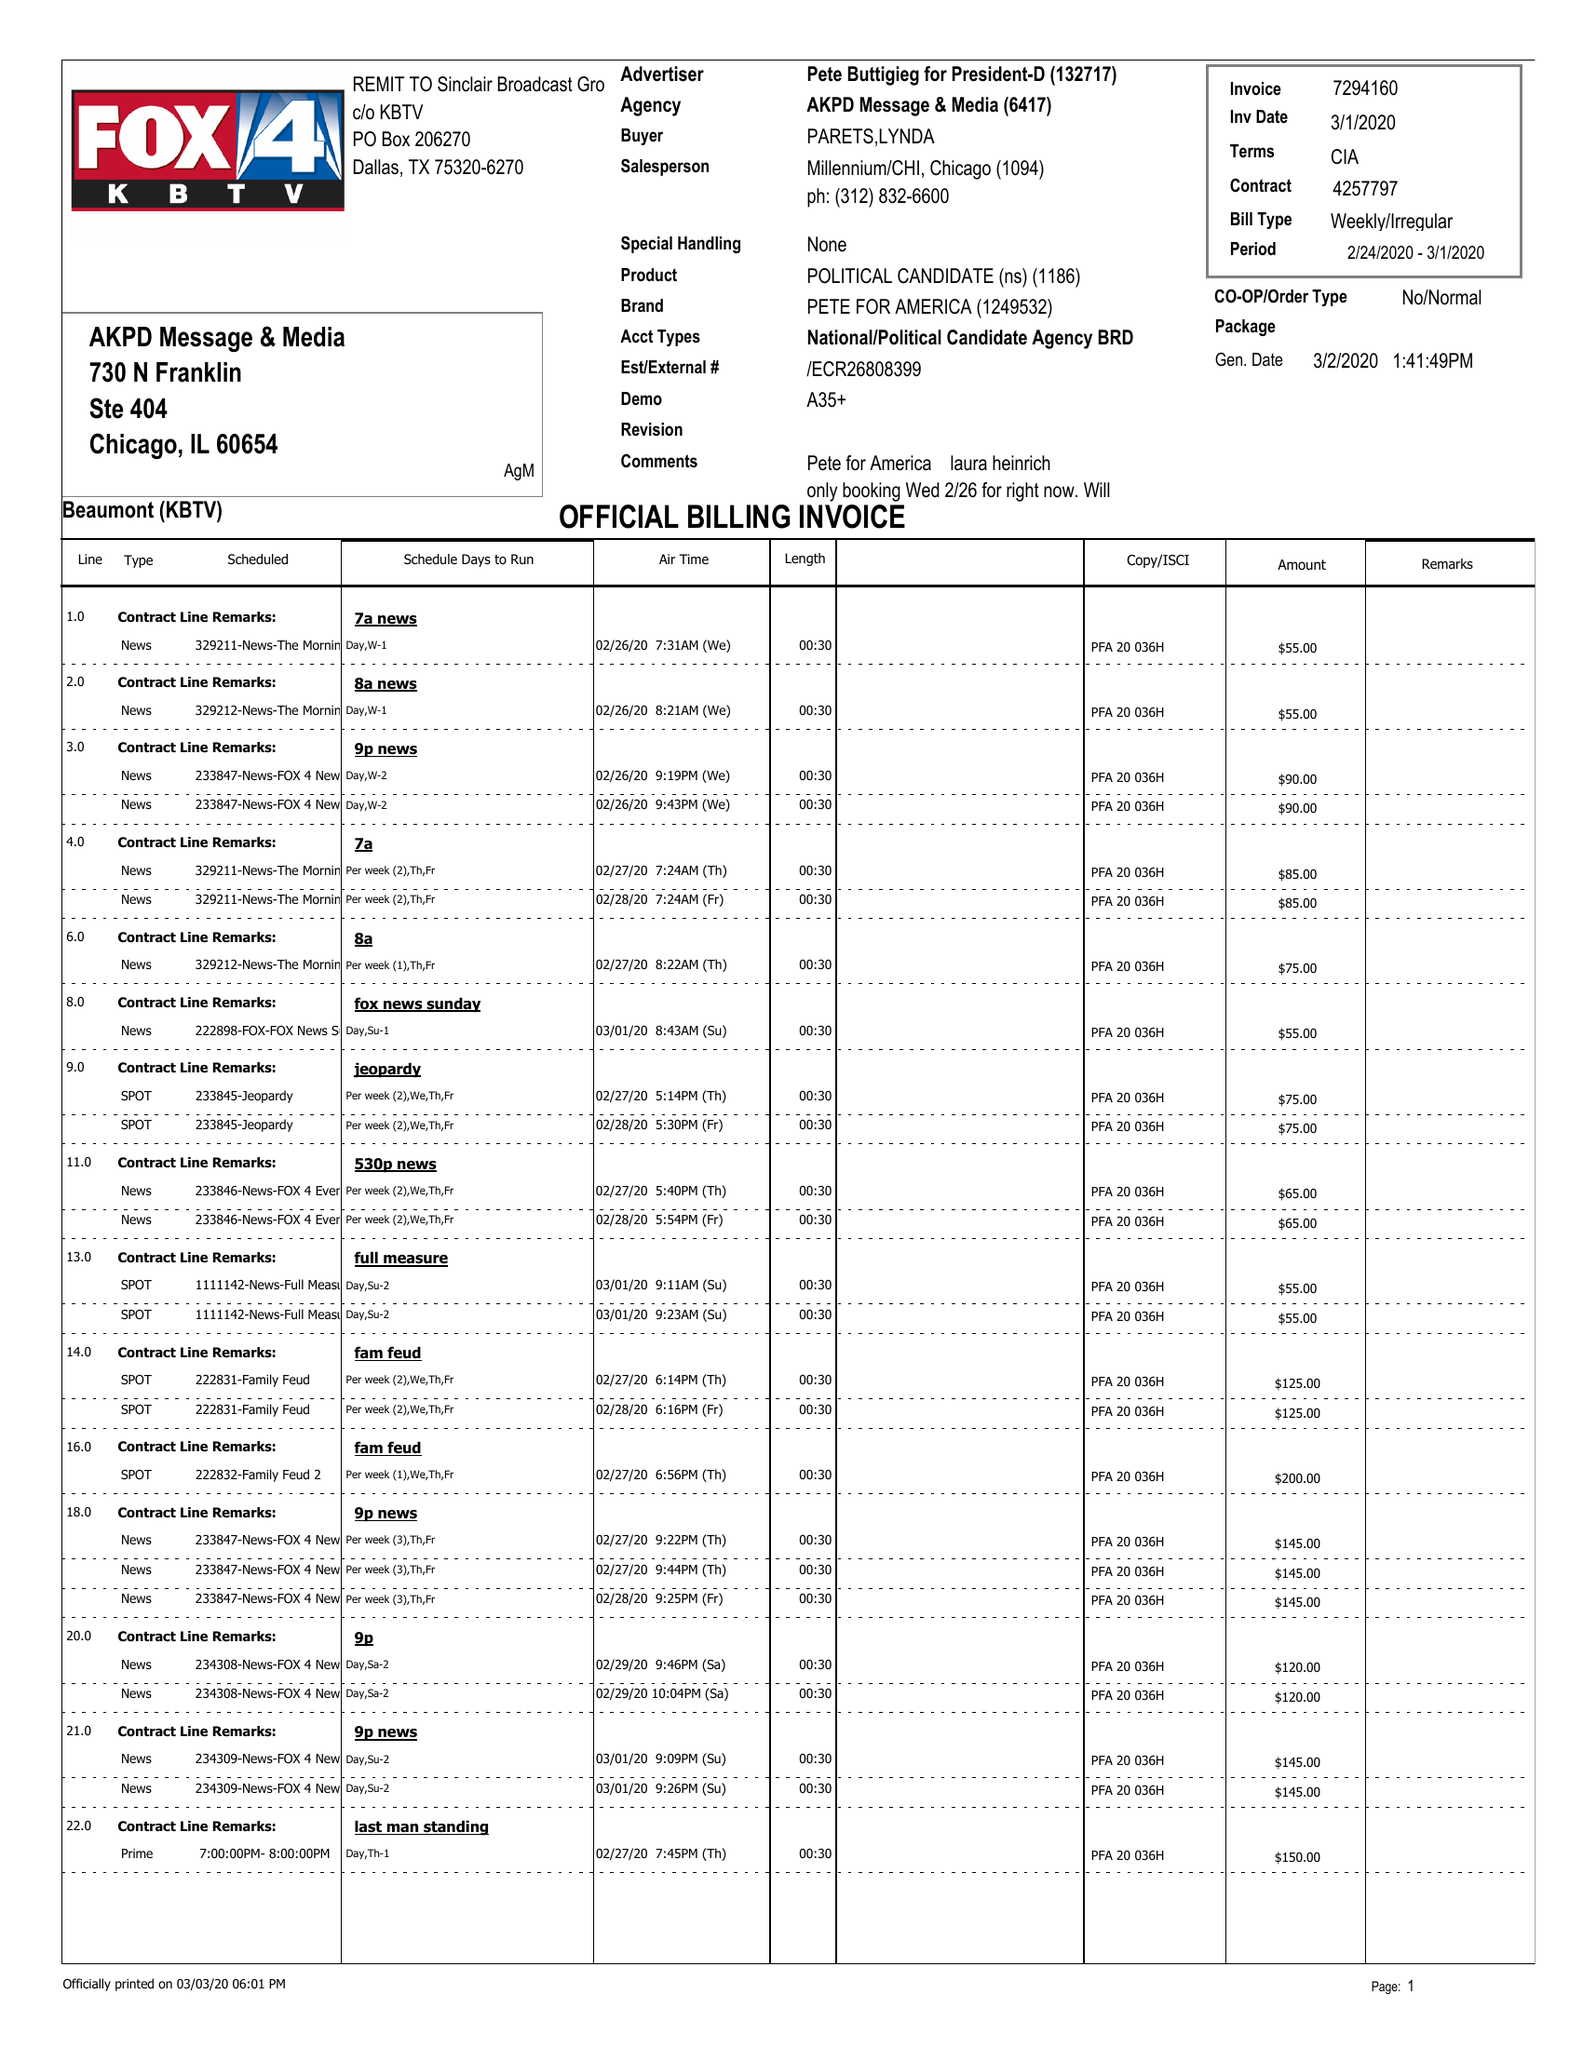What is the value for the gross_amount?
Answer the question using a single word or phrase. 2785.00 